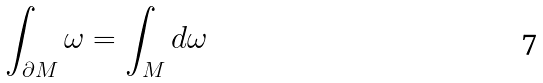Convert formula to latex. <formula><loc_0><loc_0><loc_500><loc_500>\int _ { \partial M } \omega = \int _ { M } d \omega</formula> 